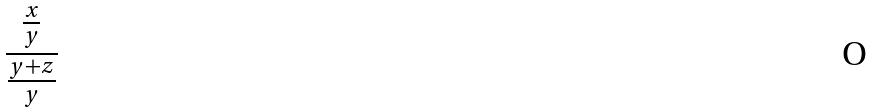<formula> <loc_0><loc_0><loc_500><loc_500>\frac { \frac { x } { y } } { \frac { y + z } { y } }</formula> 